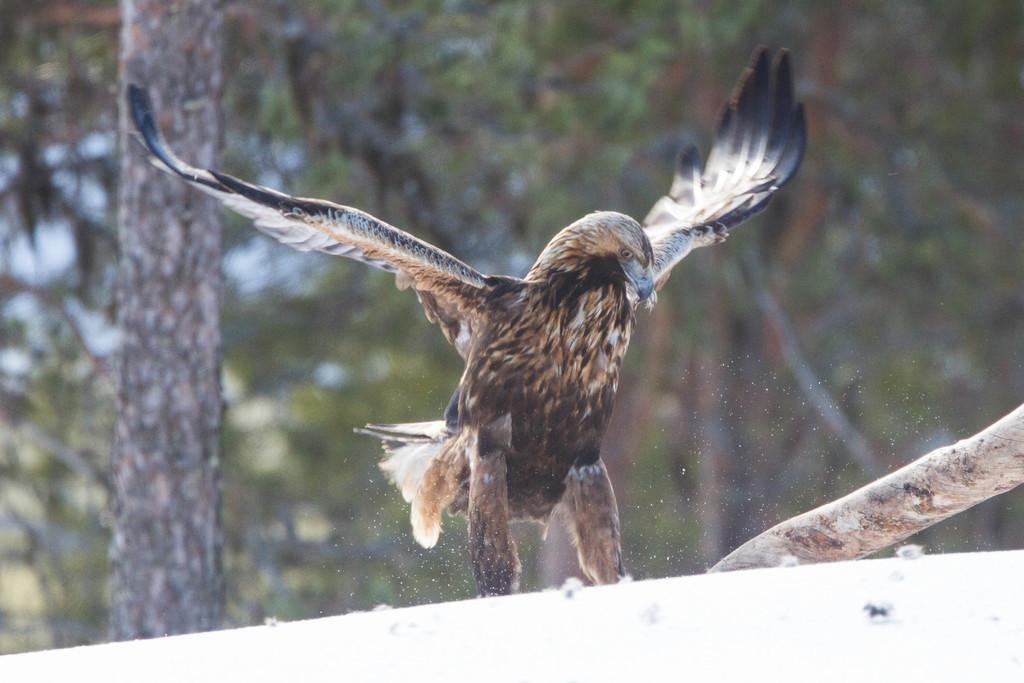What is the main subject in the center of the image? There is an eagle in the center of the image. What type of terrain is visible at the bottom of the image? There is snow at the bottom of the image. What can be seen in the background of the image? There are trees in the background of the image. What type of bushes can be seen in the image? There are no bushes present in the image; it features an eagle, snow, and trees. What emotion does the eagle appear to be experiencing in the image? The image does not convey emotions, so it is not possible to determine the eagle's emotional state. 